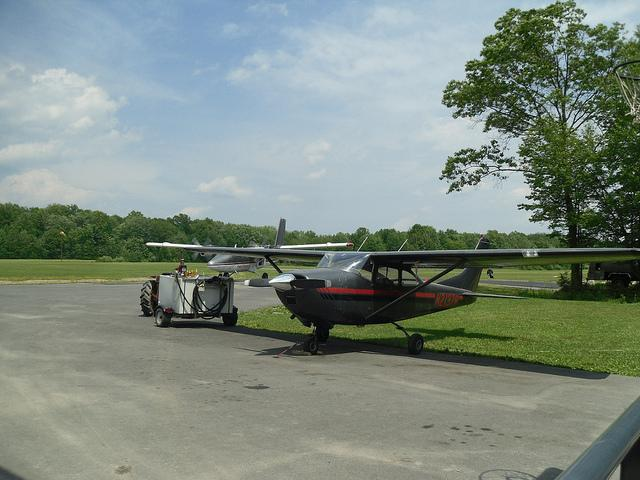What kind of transportation is shown? Please explain your reasoning. air. A plane is shown and it is a type of air transportation since it flies in the air. 